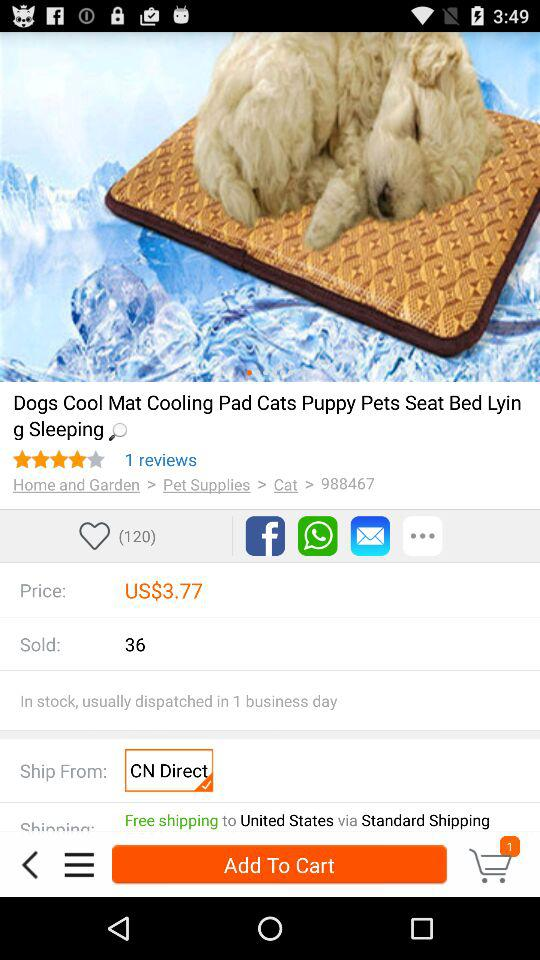How many people liked the product? The people who liked the product are 120. 